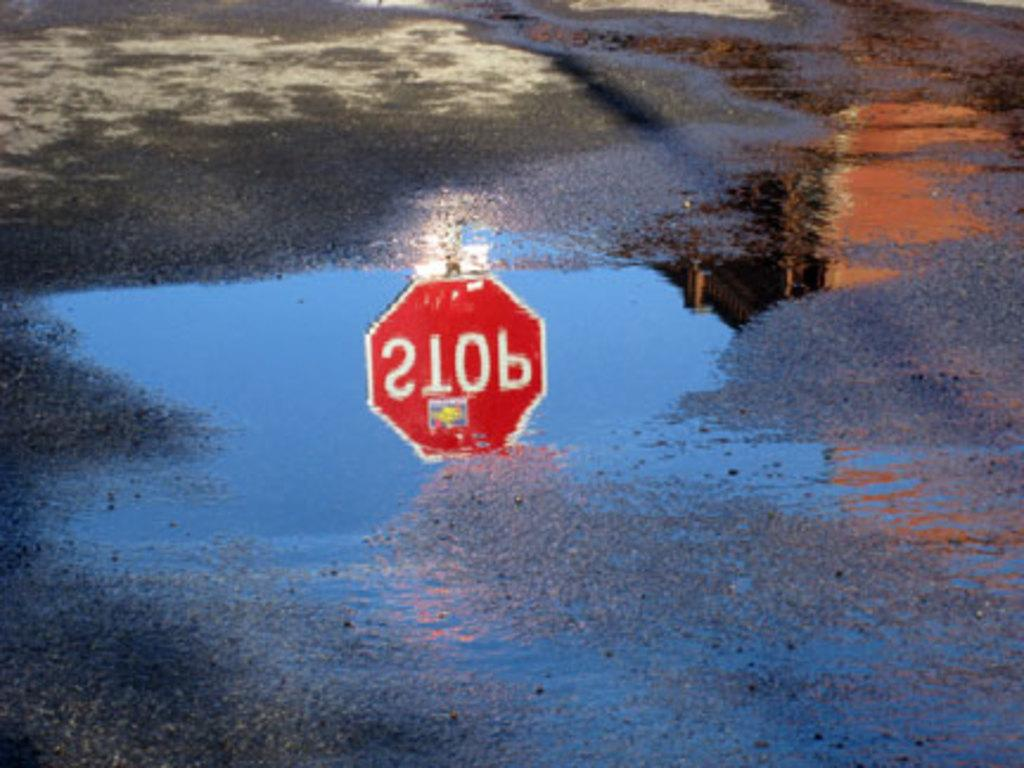Provide a one-sentence caption for the provided image. A stop sign can be seen reflected in the water. 